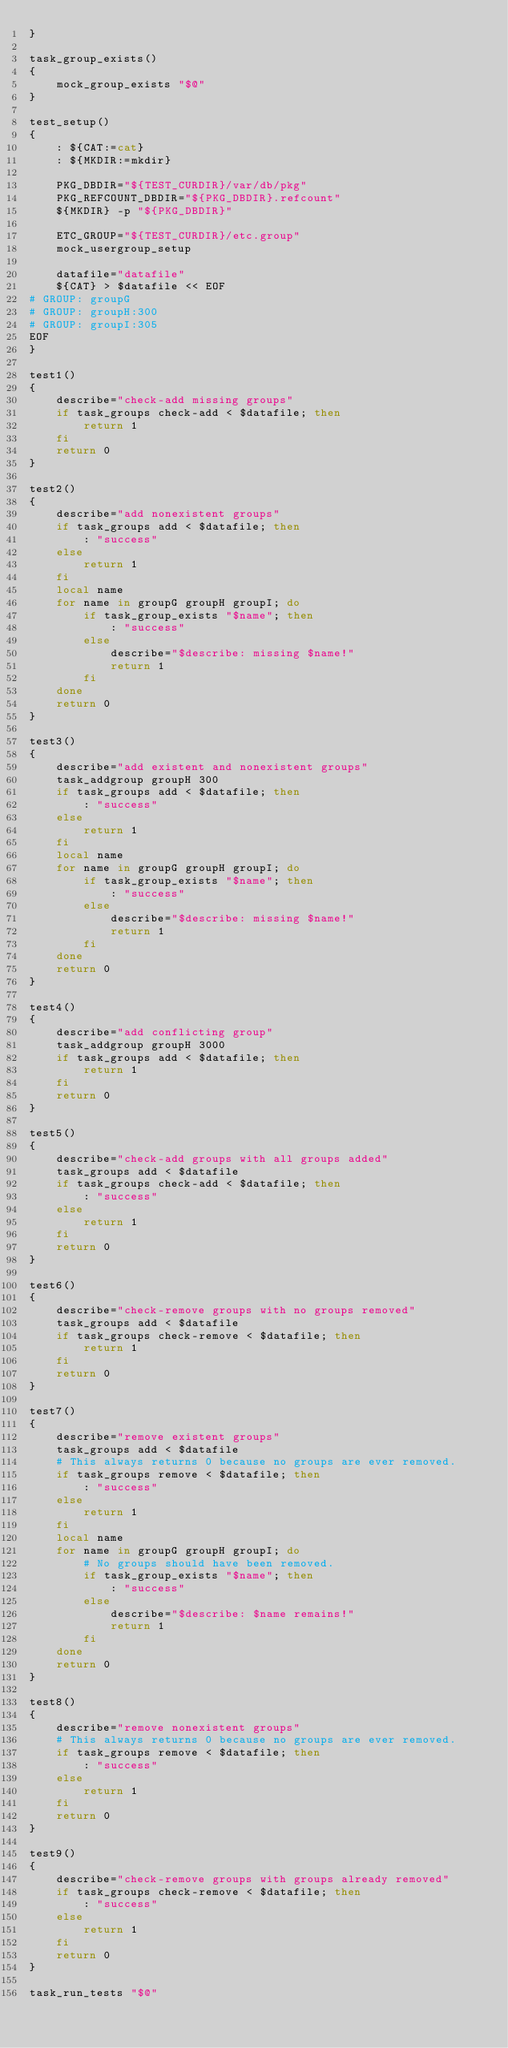Convert code to text. <code><loc_0><loc_0><loc_500><loc_500><_Bash_>}

task_group_exists()
{
	mock_group_exists "$@"
}

test_setup()
{
	: ${CAT:=cat}
	: ${MKDIR:=mkdir}

	PKG_DBDIR="${TEST_CURDIR}/var/db/pkg"
	PKG_REFCOUNT_DBDIR="${PKG_DBDIR}.refcount"
	${MKDIR} -p "${PKG_DBDIR}"

	ETC_GROUP="${TEST_CURDIR}/etc.group"
	mock_usergroup_setup

	datafile="datafile"
	${CAT} > $datafile << EOF
# GROUP: groupG
# GROUP: groupH:300
# GROUP: groupI:305
EOF
}

test1()
{
	describe="check-add missing groups"
	if task_groups check-add < $datafile; then
		return 1
	fi
	return 0
}

test2()
{
	describe="add nonexistent groups"
	if task_groups add < $datafile; then
		: "success"
	else
		return 1
	fi
	local name
	for name in groupG groupH groupI; do
		if task_group_exists "$name"; then
			: "success"
		else
			describe="$describe: missing $name!"
			return 1
		fi
	done
	return 0
}

test3()
{
	describe="add existent and nonexistent groups"
	task_addgroup groupH 300
	if task_groups add < $datafile; then
		: "success"
	else
		return 1
	fi
	local name
	for name in groupG groupH groupI; do
		if task_group_exists "$name"; then
			: "success"
		else
			describe="$describe: missing $name!"
			return 1
		fi
	done
	return 0
}

test4()
{
	describe="add conflicting group"
	task_addgroup groupH 3000
	if task_groups add < $datafile; then
		return 1
	fi
	return 0
}

test5()
{
	describe="check-add groups with all groups added"
	task_groups add < $datafile
	if task_groups check-add < $datafile; then
		: "success"
	else
		return 1
	fi
	return 0
}

test6()
{
	describe="check-remove groups with no groups removed"
	task_groups add < $datafile
	if task_groups check-remove < $datafile; then
		return 1
	fi
	return 0
}

test7()
{
	describe="remove existent groups"
	task_groups add < $datafile
	# This always returns 0 because no groups are ever removed.
	if task_groups remove < $datafile; then
		: "success"
	else
		return 1
	fi
	local name
	for name in groupG groupH groupI; do
		# No groups should have been removed.
		if task_group_exists "$name"; then
			: "success"
		else
			describe="$describe: $name remains!"
			return 1
		fi
	done
	return 0
}

test8()
{
	describe="remove nonexistent groups"
	# This always returns 0 because no groups are ever removed.
	if task_groups remove < $datafile; then
		: "success"
	else
		return 1
	fi
	return 0
}

test9()
{
	describe="check-remove groups with groups already removed"
	if task_groups check-remove < $datafile; then
		: "success"
	else
		return 1
	fi
	return 0
}

task_run_tests "$@"
</code> 